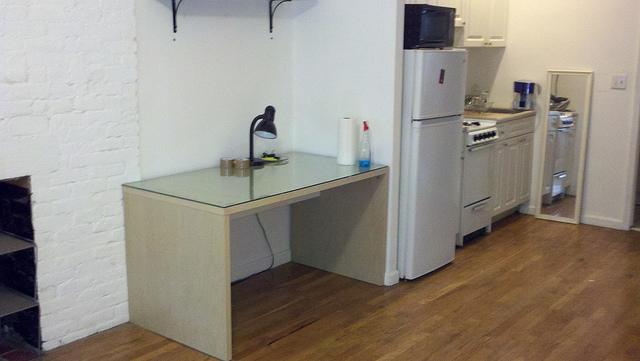What object is out of place in the kitchen?

Choices:
A) stove
B) microwave
C) mirror
D) refrigerator mirror 